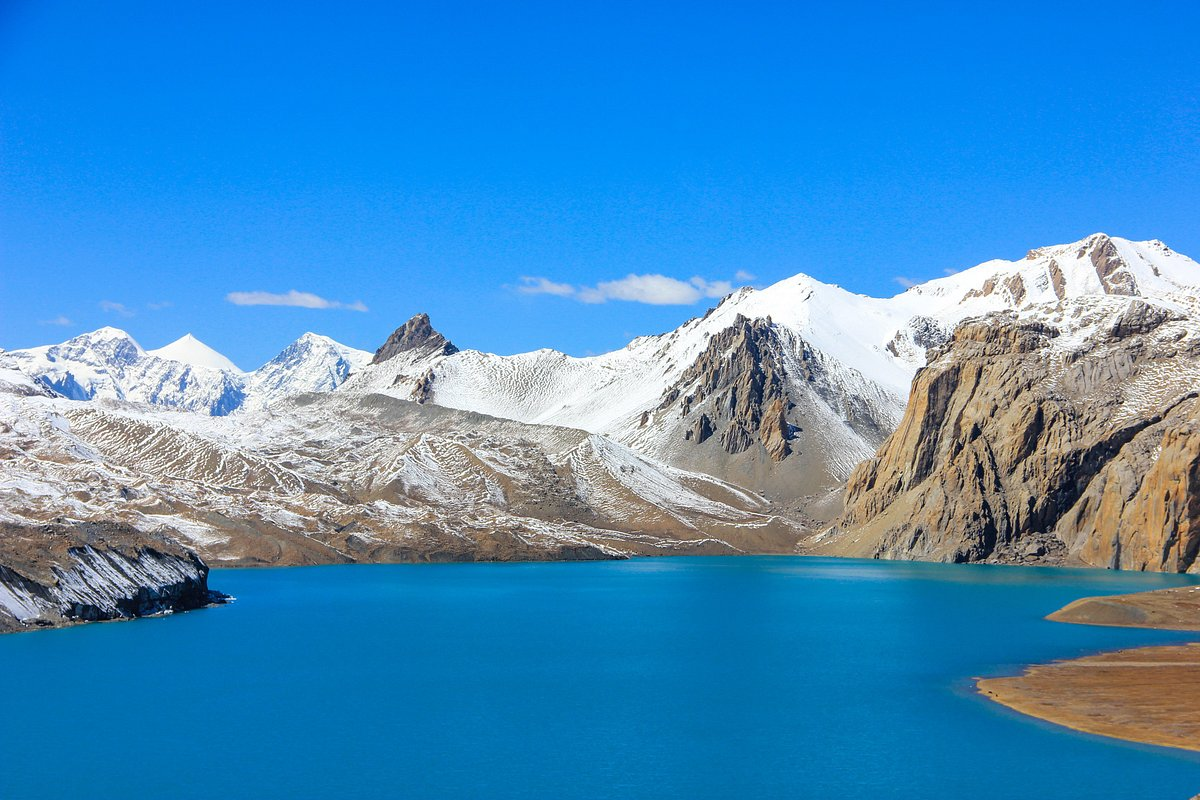What wildlife might inhabit this kind of environment? High-altitude environments like this one often host a range of specialized flora and fauna adept at surviving in harsh conditions. Animals may include mountain goats or sheep, which are agile climbers and can navigate steep rocky slopes. Smaller mammals such as pikas and marmots might be found in rocky areas. Birds adapted to high elevations, such as certain species of finches and raptors, can also be spotted in the skies or perched on outcrops. Vegetation is usually sparse but may include hardy grasses, mosses, and alpine flowers that have adapted to the cold, windy, and often dry conditions. 